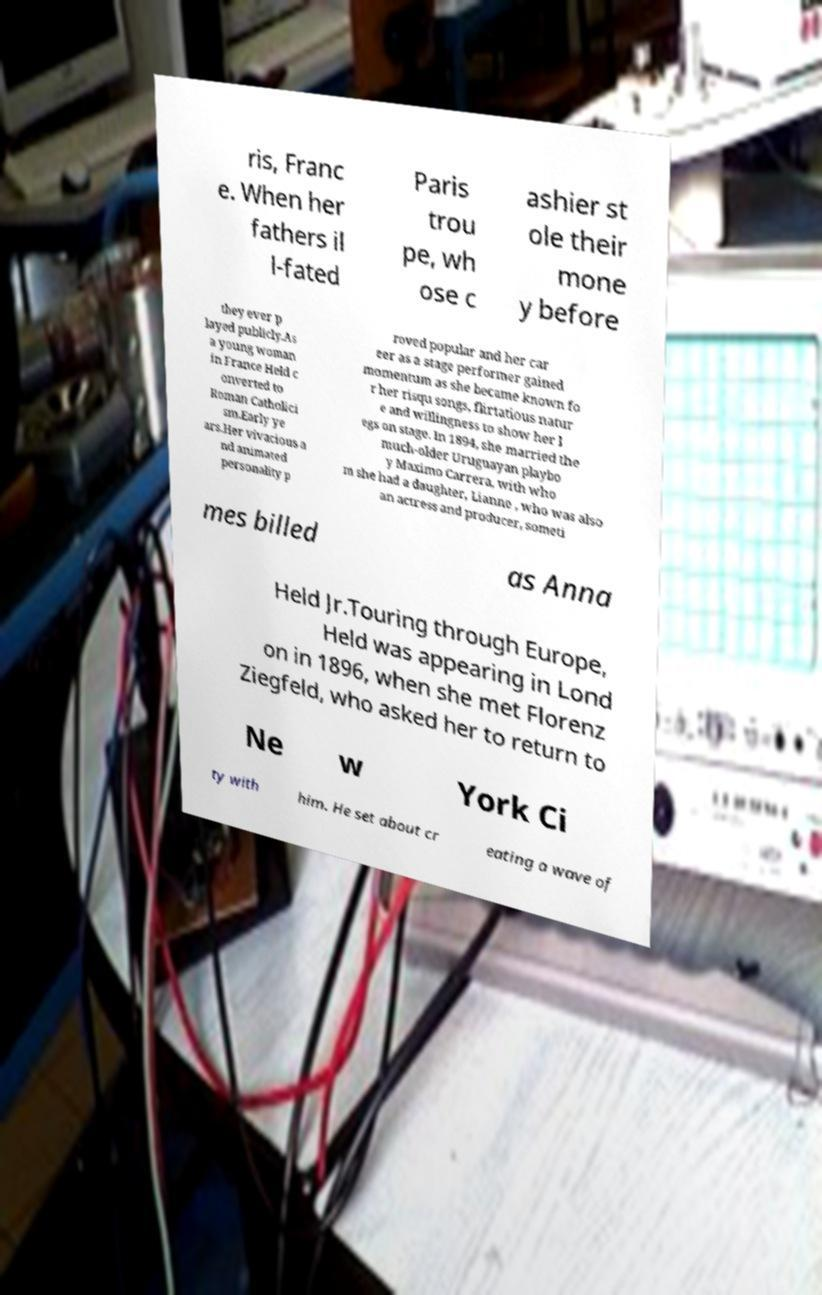Could you extract and type out the text from this image? ris, Franc e. When her fathers il l-fated Paris trou pe, wh ose c ashier st ole their mone y before they ever p layed publicly.As a young woman in France Held c onverted to Roman Catholici sm.Early ye ars.Her vivacious a nd animated personality p roved popular and her car eer as a stage performer gained momentum as she became known fo r her risqu songs, flirtatious natur e and willingness to show her l egs on stage. In 1894, she married the much-older Uruguayan playbo y Maximo Carrera, with who m she had a daughter, Lianne , who was also an actress and producer, someti mes billed as Anna Held Jr.Touring through Europe, Held was appearing in Lond on in 1896, when she met Florenz Ziegfeld, who asked her to return to Ne w York Ci ty with him. He set about cr eating a wave of 